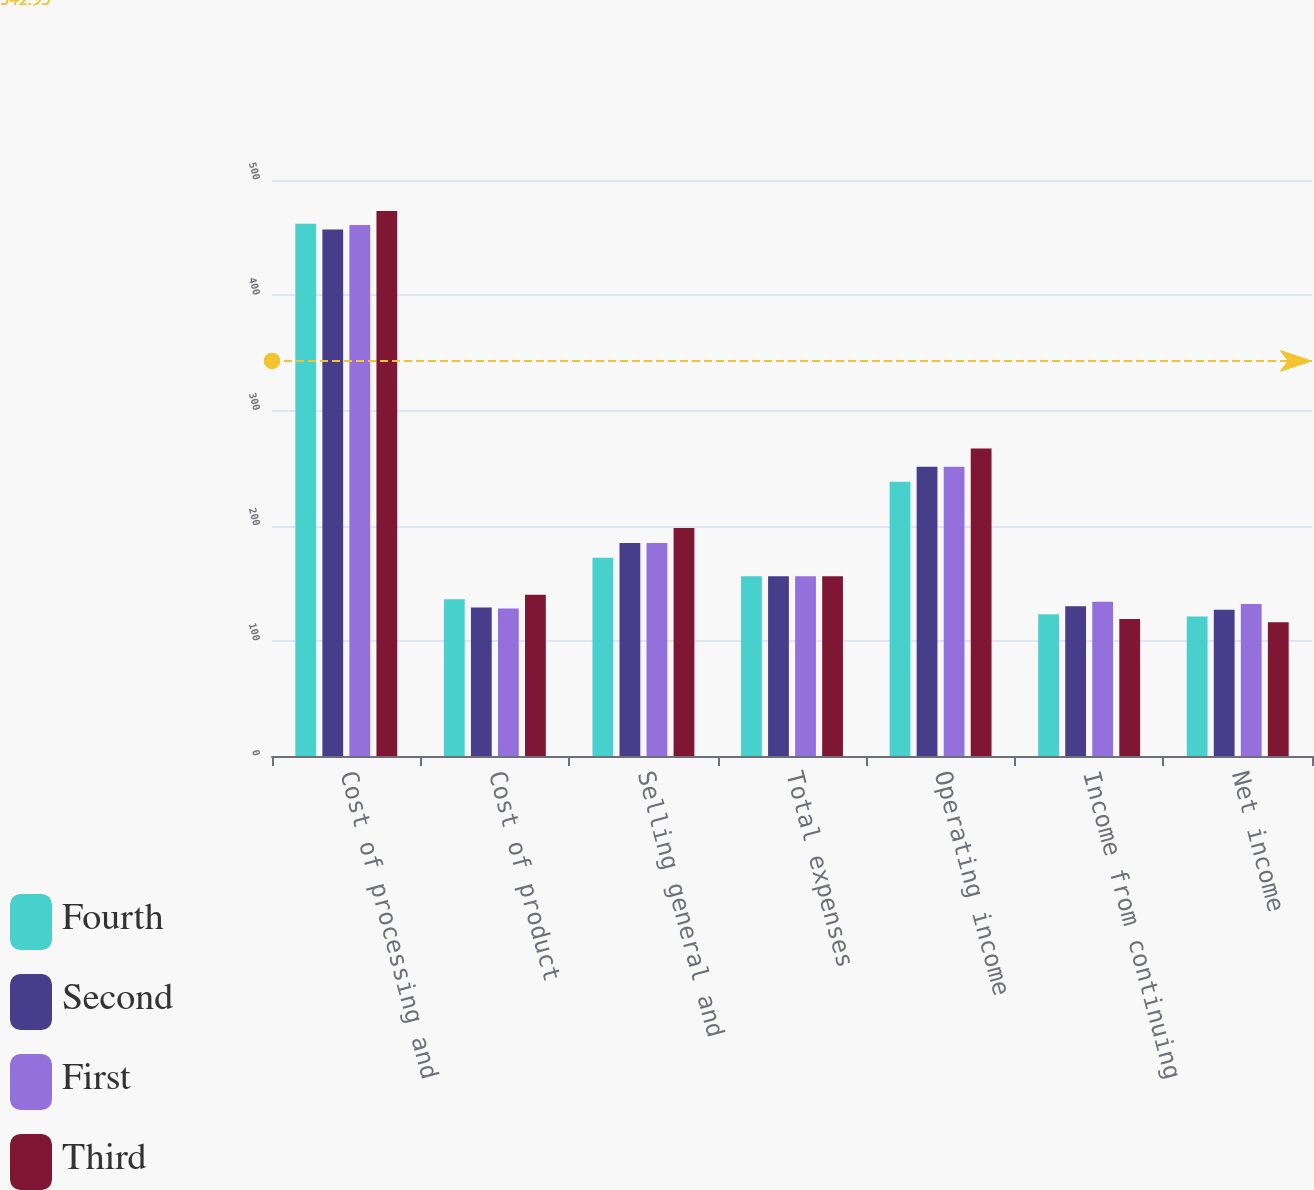<chart> <loc_0><loc_0><loc_500><loc_500><stacked_bar_chart><ecel><fcel>Cost of processing and<fcel>Cost of product<fcel>Selling general and<fcel>Total expenses<fcel>Operating income<fcel>Income from continuing<fcel>Net income<nl><fcel>Fourth<fcel>462<fcel>136<fcel>172<fcel>156<fcel>238<fcel>123<fcel>121<nl><fcel>Second<fcel>457<fcel>129<fcel>185<fcel>156<fcel>251<fcel>130<fcel>127<nl><fcel>First<fcel>461<fcel>128<fcel>185<fcel>156<fcel>251<fcel>134<fcel>132<nl><fcel>Third<fcel>473<fcel>140<fcel>198<fcel>156<fcel>267<fcel>119<fcel>116<nl></chart> 